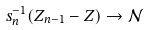Convert formula to latex. <formula><loc_0><loc_0><loc_500><loc_500>s _ { n } ^ { - 1 } ( Z _ { n - 1 } - Z ) \to \mathcal { N }</formula> 